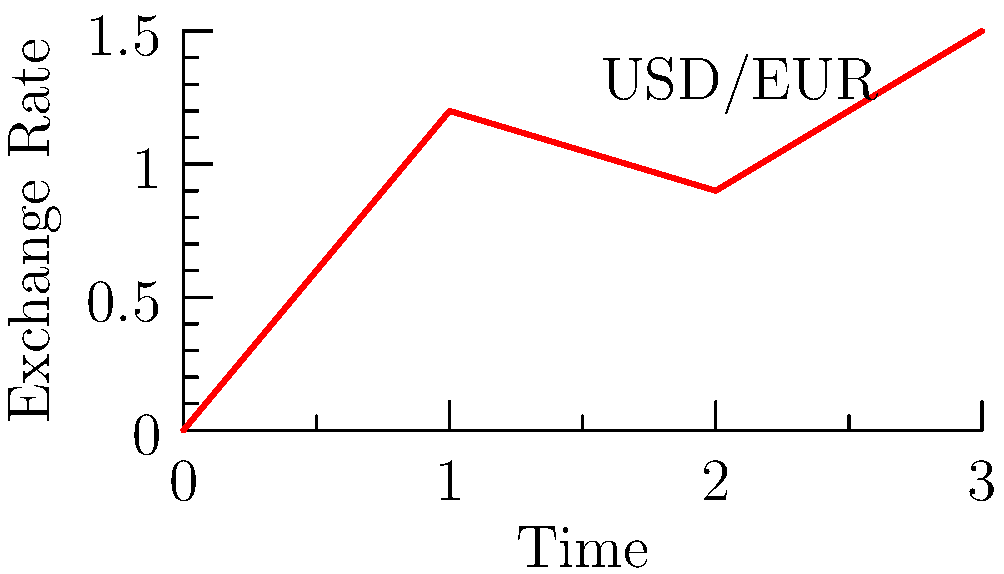As a Monegasque businessman, you're analyzing the USD/EUR exchange rate over a 3-day period. The graph shows the exchange rate vector where each component represents a day's rate. If you exchanged 100,000 EUR to USD on day 0 and converted it back to EUR on day 3, what would be your profit or loss in EUR, assuming no transaction fees? Let's approach this step-by-step:

1) On day 0, the exchange rate is 1 USD = 1 EUR.
   So, 100,000 EUR = 100,000 USD

2) On day 3, the exchange rate is 1 USD = 1.5 EUR.
   To convert back to EUR, we use:
   $100,000 \text{ USD} \times \frac{1.5 \text{ EUR}}{1 \text{ USD}} = 150,000 \text{ EUR}$

3) To calculate the profit/loss:
   $\text{Profit/Loss} = \text{Final Amount} - \text{Initial Amount}$
   $= 150,000 \text{ EUR} - 100,000 \text{ EUR} = 50,000 \text{ EUR}$

Therefore, you would make a profit of 50,000 EUR from this exchange.
Answer: 50,000 EUR profit 